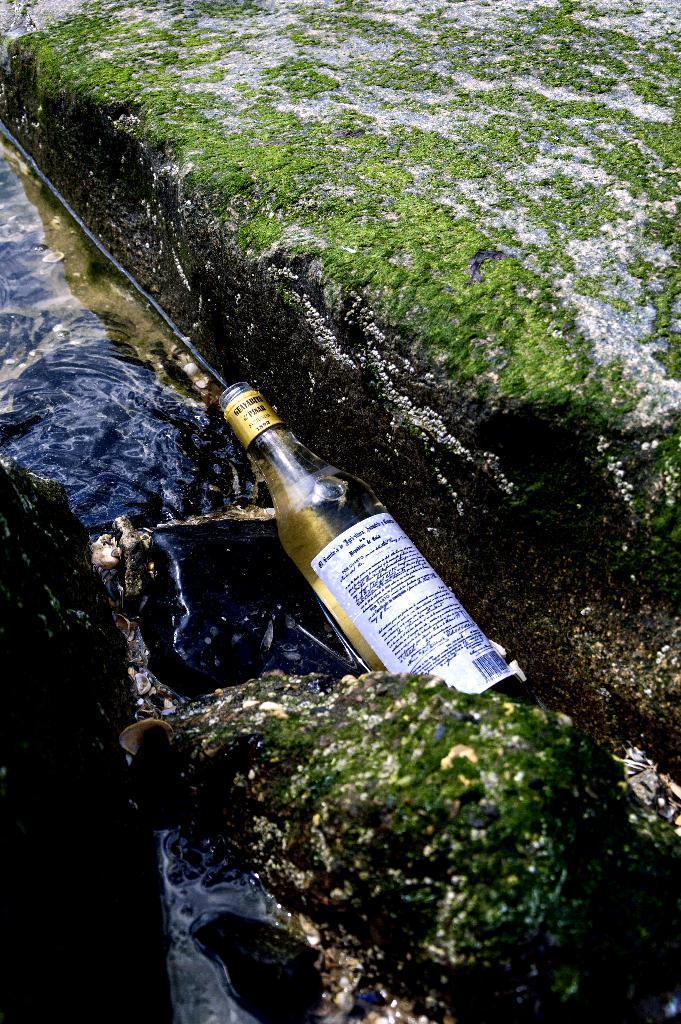What type of container is visible in the image? There is a glass bottle in the image. What is the main liquid present in the image? There is water in the image. What type of organic growth can be seen on the rocks in the image? Algae are present on the rocks in the image. What type of toothbrush is visible in the image? There is no toothbrush present in the image. What color is the flag flying in the background of the image? There is no flag present in the image. 